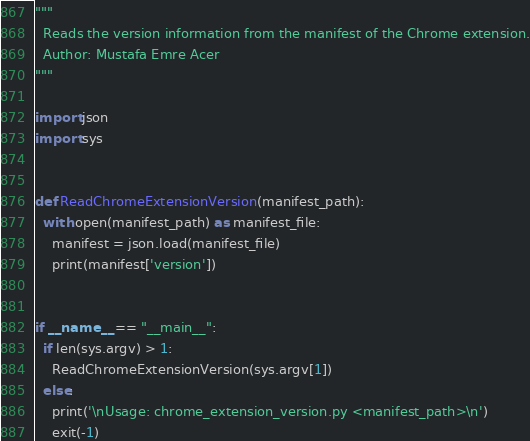<code> <loc_0><loc_0><loc_500><loc_500><_Python_>"""
  Reads the version information from the manifest of the Chrome extension.
  Author: Mustafa Emre Acer
"""

import json
import sys


def ReadChromeExtensionVersion(manifest_path):
  with open(manifest_path) as manifest_file:
    manifest = json.load(manifest_file)
    print(manifest['version'])


if __name__ == "__main__":
  if len(sys.argv) > 1:
    ReadChromeExtensionVersion(sys.argv[1])
  else:
    print('\nUsage: chrome_extension_version.py <manifest_path>\n')
    exit(-1)
</code> 